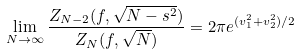Convert formula to latex. <formula><loc_0><loc_0><loc_500><loc_500>\lim _ { N \to \infty } \frac { Z _ { N - 2 } ( f , \sqrt { N - s ^ { 2 } } ) } { Z _ { N } ( f , \sqrt { N } ) } = 2 \pi e ^ { ( v _ { 1 } ^ { 2 } + v _ { 2 } ^ { 2 } ) / 2 }</formula> 